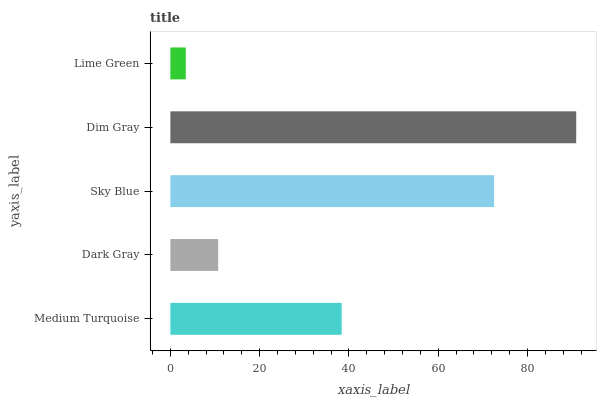Is Lime Green the minimum?
Answer yes or no. Yes. Is Dim Gray the maximum?
Answer yes or no. Yes. Is Dark Gray the minimum?
Answer yes or no. No. Is Dark Gray the maximum?
Answer yes or no. No. Is Medium Turquoise greater than Dark Gray?
Answer yes or no. Yes. Is Dark Gray less than Medium Turquoise?
Answer yes or no. Yes. Is Dark Gray greater than Medium Turquoise?
Answer yes or no. No. Is Medium Turquoise less than Dark Gray?
Answer yes or no. No. Is Medium Turquoise the high median?
Answer yes or no. Yes. Is Medium Turquoise the low median?
Answer yes or no. Yes. Is Sky Blue the high median?
Answer yes or no. No. Is Dim Gray the low median?
Answer yes or no. No. 